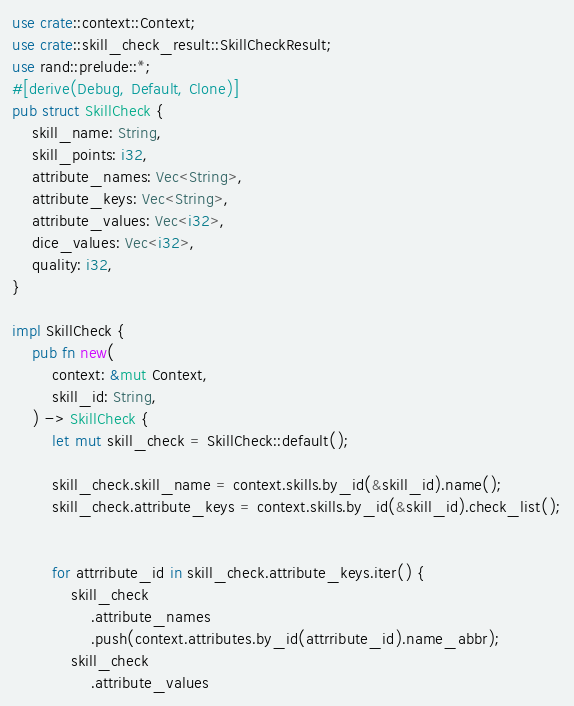Convert code to text. <code><loc_0><loc_0><loc_500><loc_500><_Rust_>use crate::context::Context;
use crate::skill_check_result::SkillCheckResult;
use rand::prelude::*;
#[derive(Debug, Default, Clone)]
pub struct SkillCheck {
    skill_name: String,
    skill_points: i32,
    attribute_names: Vec<String>,
    attribute_keys: Vec<String>,
    attribute_values: Vec<i32>,
    dice_values: Vec<i32>,
    quality: i32,
}

impl SkillCheck {
    pub fn new(
        context: &mut Context,   
        skill_id: String,
    ) -> SkillCheck {
        let mut skill_check = SkillCheck::default();

        skill_check.skill_name = context.skills.by_id(&skill_id).name();
        skill_check.attribute_keys = context.skills.by_id(&skill_id).check_list();
        

        for attrribute_id in skill_check.attribute_keys.iter() {
            skill_check
                .attribute_names
                .push(context.attributes.by_id(attrribute_id).name_abbr);
            skill_check
                .attribute_values</code> 